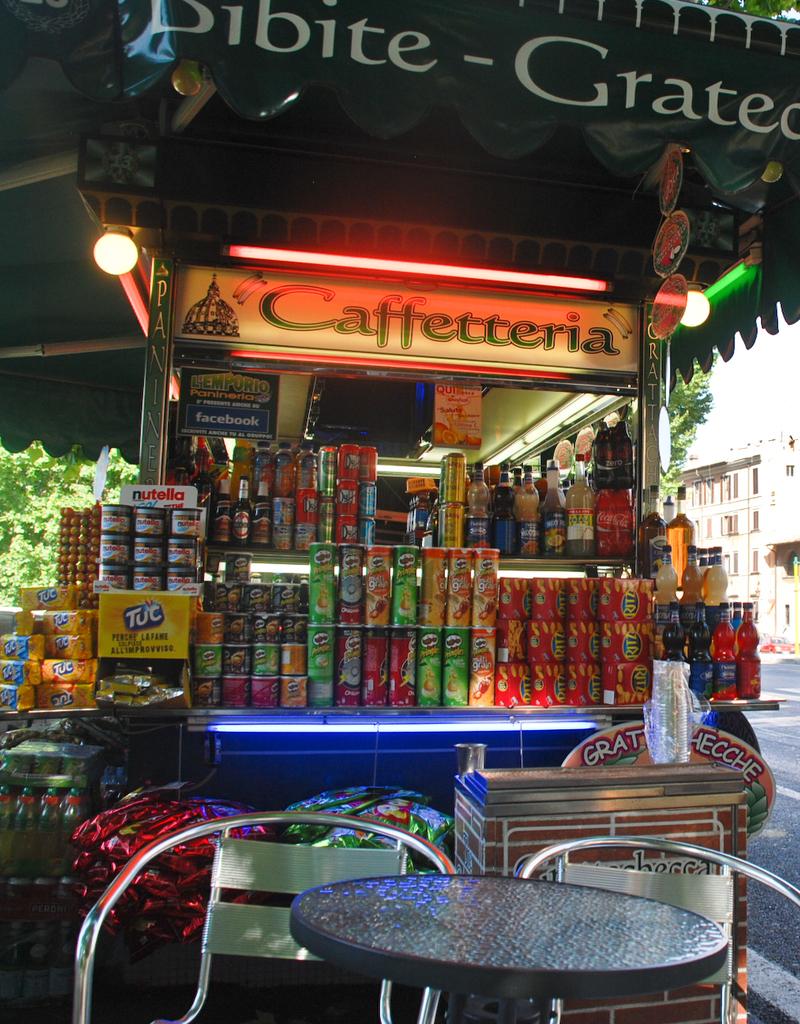What is the name of the drink stand?
Your answer should be compact. Caffetteria. What is one of the brand names?
Your response must be concise. Nutella. 